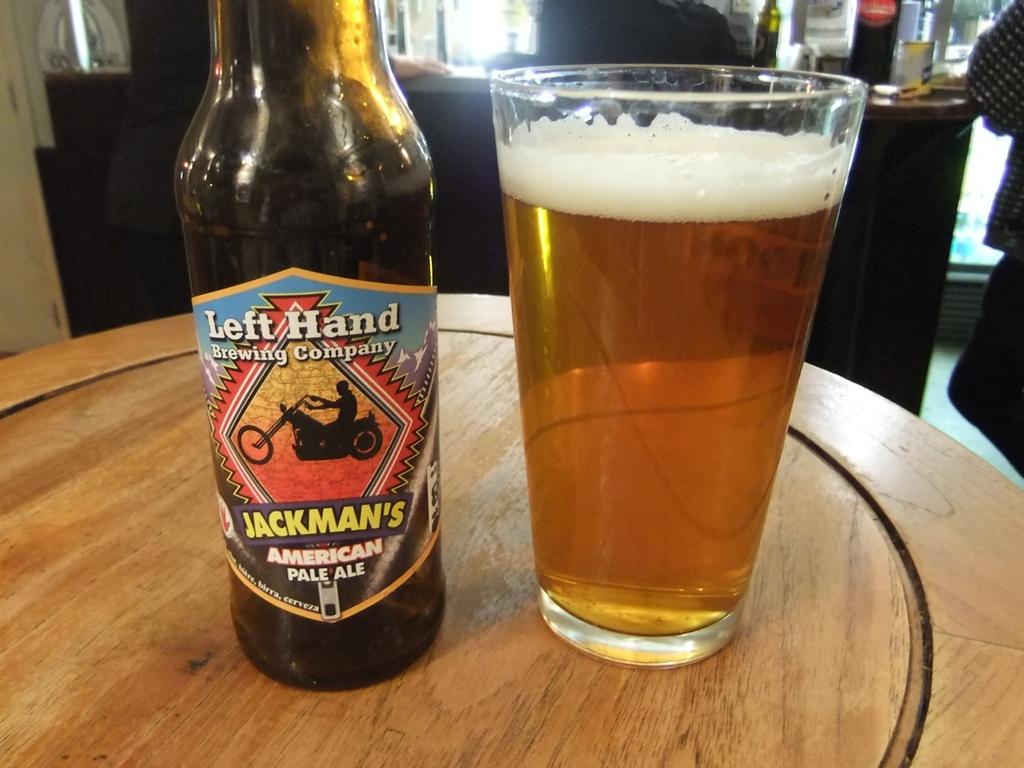What type of beer is this?
Ensure brevity in your answer.  Jackman's american pale ale. What is the brand of the pale ale?
Provide a short and direct response. Left hand. 